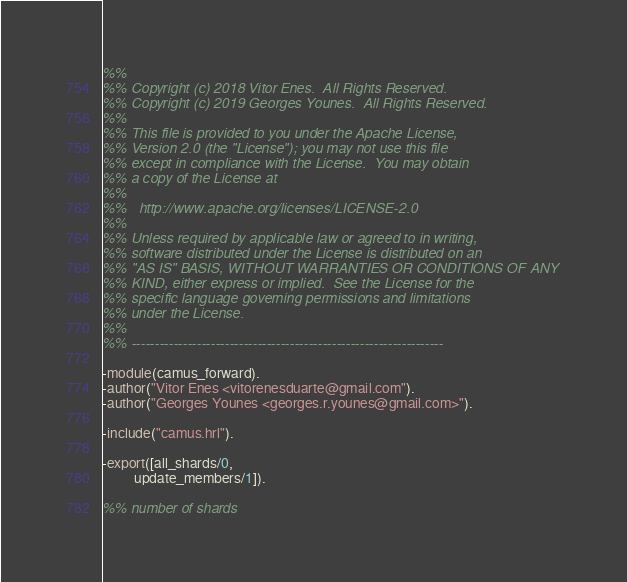Convert code to text. <code><loc_0><loc_0><loc_500><loc_500><_Erlang_>%%
%% Copyright (c) 2018 Vitor Enes.  All Rights Reserved.
%% Copyright (c) 2019 Georges Younes.  All Rights Reserved.
%%
%% This file is provided to you under the Apache License,
%% Version 2.0 (the "License"); you may not use this file
%% except in compliance with the License.  You may obtain
%% a copy of the License at
%%
%%   http://www.apache.org/licenses/LICENSE-2.0
%%
%% Unless required by applicable law or agreed to in writing,
%% software distributed under the License is distributed on an
%% "AS IS" BASIS, WITHOUT WARRANTIES OR CONDITIONS OF ANY
%% KIND, either express or implied.  See the License for the
%% specific language governing permissions and limitations
%% under the License.
%%
%% -------------------------------------------------------------------

-module(camus_forward).
-author("Vitor Enes <vitorenesduarte@gmail.com").
-author("Georges Younes <georges.r.younes@gmail.com>").

-include("camus.hrl").

-export([all_shards/0,
         update_members/1]).

%% number of shards</code> 